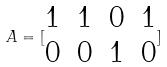<formula> <loc_0><loc_0><loc_500><loc_500>A = [ \begin{matrix} 1 & 1 & 0 & 1 \\ 0 & 0 & 1 & 0 \end{matrix} ]</formula> 